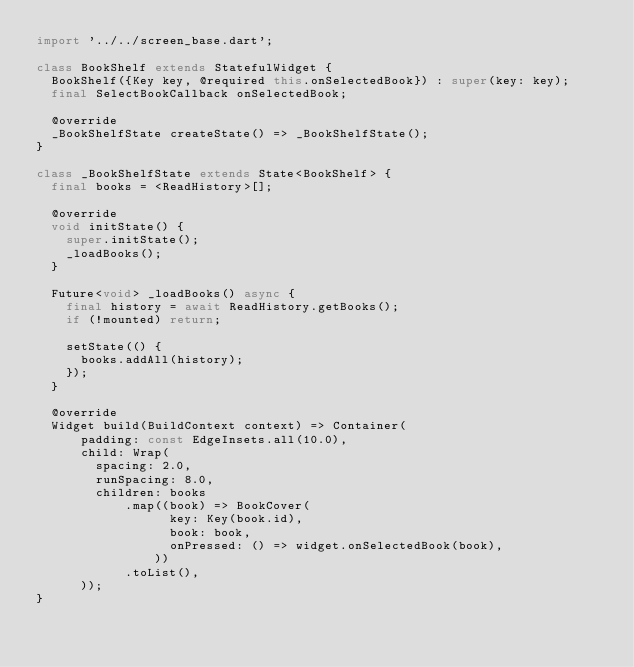Convert code to text. <code><loc_0><loc_0><loc_500><loc_500><_Dart_>import '../../screen_base.dart';

class BookShelf extends StatefulWidget {
  BookShelf({Key key, @required this.onSelectedBook}) : super(key: key);
  final SelectBookCallback onSelectedBook;

  @override
  _BookShelfState createState() => _BookShelfState();
}

class _BookShelfState extends State<BookShelf> {
  final books = <ReadHistory>[];

  @override
  void initState() {
    super.initState();
    _loadBooks();
  }

  Future<void> _loadBooks() async {
    final history = await ReadHistory.getBooks();
    if (!mounted) return;

    setState(() {
      books.addAll(history);
    });
  }

  @override
  Widget build(BuildContext context) => Container(
      padding: const EdgeInsets.all(10.0),
      child: Wrap(
        spacing: 2.0,
        runSpacing: 8.0,
        children: books
            .map((book) => BookCover(
                  key: Key(book.id),
                  book: book,
                  onPressed: () => widget.onSelectedBook(book),
                ))
            .toList(),
      ));
}
</code> 